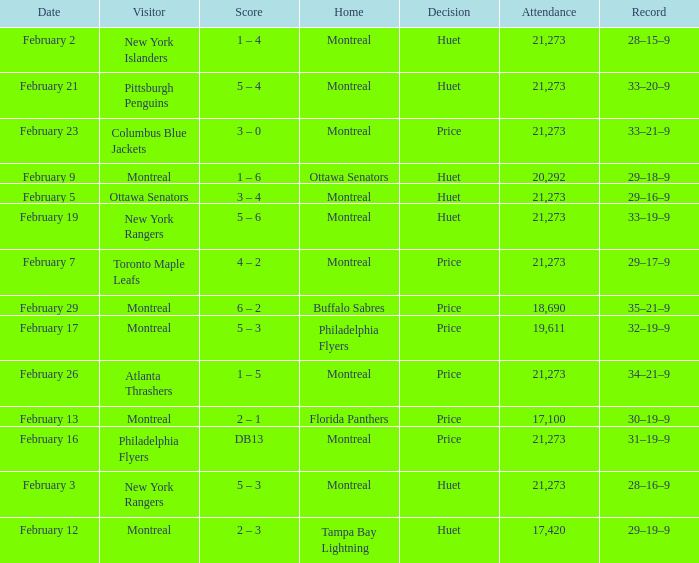Who was the visiting team at the game when the Canadiens had a record of 30–19–9? Montreal. 